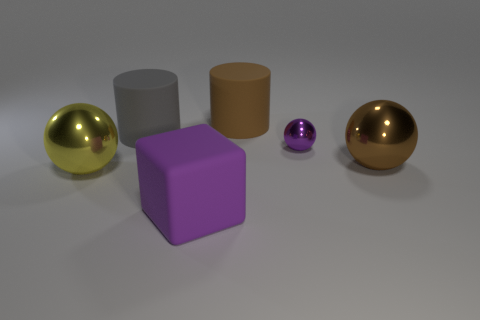What color is the other large object that is the same shape as the large yellow shiny thing?
Your answer should be compact. Brown. How many objects are balls that are right of the large brown cylinder or things in front of the brown shiny object?
Keep it short and to the point. 4. What is the shape of the yellow shiny thing?
Offer a terse response. Sphere. The small thing that is the same color as the block is what shape?
Your answer should be compact. Sphere. What number of other purple things have the same material as the tiny thing?
Your answer should be compact. 0. The large rubber block is what color?
Your answer should be compact. Purple. What color is the rubber cylinder that is the same size as the brown matte thing?
Provide a short and direct response. Gray. Is there a big rubber block that has the same color as the small shiny thing?
Make the answer very short. Yes. There is a purple object that is behind the brown ball; is its shape the same as the large shiny object behind the yellow thing?
Ensure brevity in your answer.  Yes. There is a thing that is the same color as the large block; what is its size?
Provide a short and direct response. Small. 